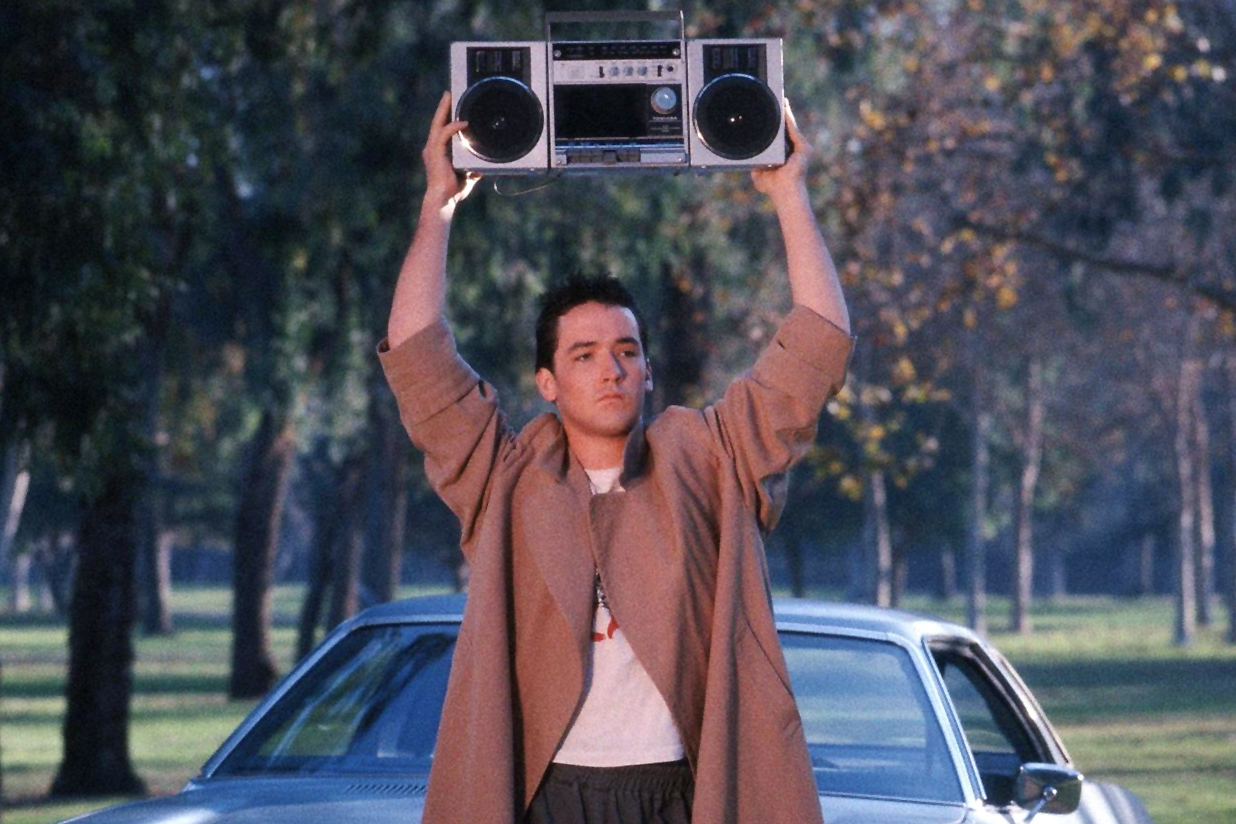Imagine if the scene took place in a futuristic city. Describe Lloyd Dobler and his surroundings. In a futuristic city, Lloyd Dobler's grand gesture would take on an entirely new dimension. Instead of a quiet suburban park, he stands amidst towering skyscrapers made of gleaming glass and steel. Neon lights and holographic advertisements create a vibrant, pulsating backdrop, casting colorful reflections onto Lloyd's face. He is dressed in a sleek, high-tech trench coat made of smart fabric that changes color to match the intensity of the moment. The boombox he holds is now a compact, floating device with transparent panels and pulsating LED lights, emitting a powerful, high-fidelity sound that resonates through the bustling cityscape. The futuristic setting amplifies the drama and adds a layer of technological wonder to his timeless act of love and defiance. What if the boombox Lloyd is holding starts playing a song that wasn't from the 80s but from the future? Describe the song and its potential impact on the scene. If the boombox Lloyd is holding starts playing a song from the future, the impact on the scene would be profound. Imagine a futuristic ballad with ethereal synths, a hauntingly beautiful melody, and vocals enhanced with subtle digital effects, giving the singer’s voice an otherworldly quality. The song’s lyrics speak of timeless love, connection through the ages, and the transcendent power of emotion. As this futuristic tune fills the air, the scene transforms from a simple act of romantic defiance to a moment that feels both timeless and forward-looking. The advanced, yet emotionally resonant music would deepen the audience's connection to Lloyd's gesture, making it feel even more universal and enduring, suggesting that the power of love and music transcends time and technological advancement. 